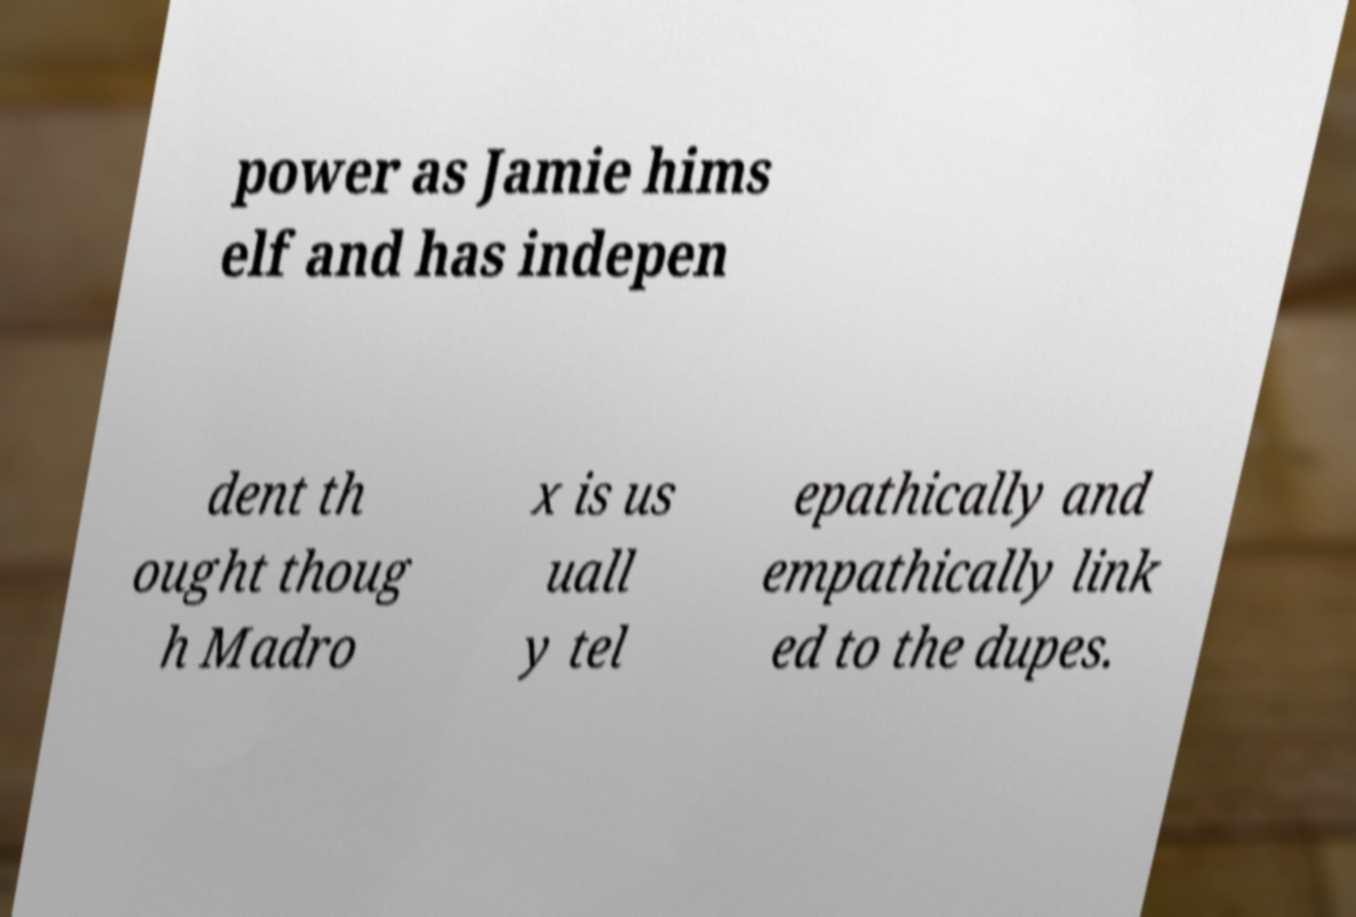For documentation purposes, I need the text within this image transcribed. Could you provide that? power as Jamie hims elf and has indepen dent th ought thoug h Madro x is us uall y tel epathically and empathically link ed to the dupes. 